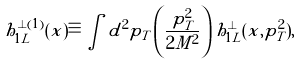<formula> <loc_0><loc_0><loc_500><loc_500>h _ { 1 L } ^ { \perp ( 1 ) } ( x ) \equiv \int d ^ { 2 } p _ { T } \, { \left ( \frac { p _ { T } ^ { 2 } } { 2 M ^ { 2 } } \right ) } \, h _ { 1 L } ^ { \perp } ( x , p _ { T } ^ { 2 } ) ,</formula> 